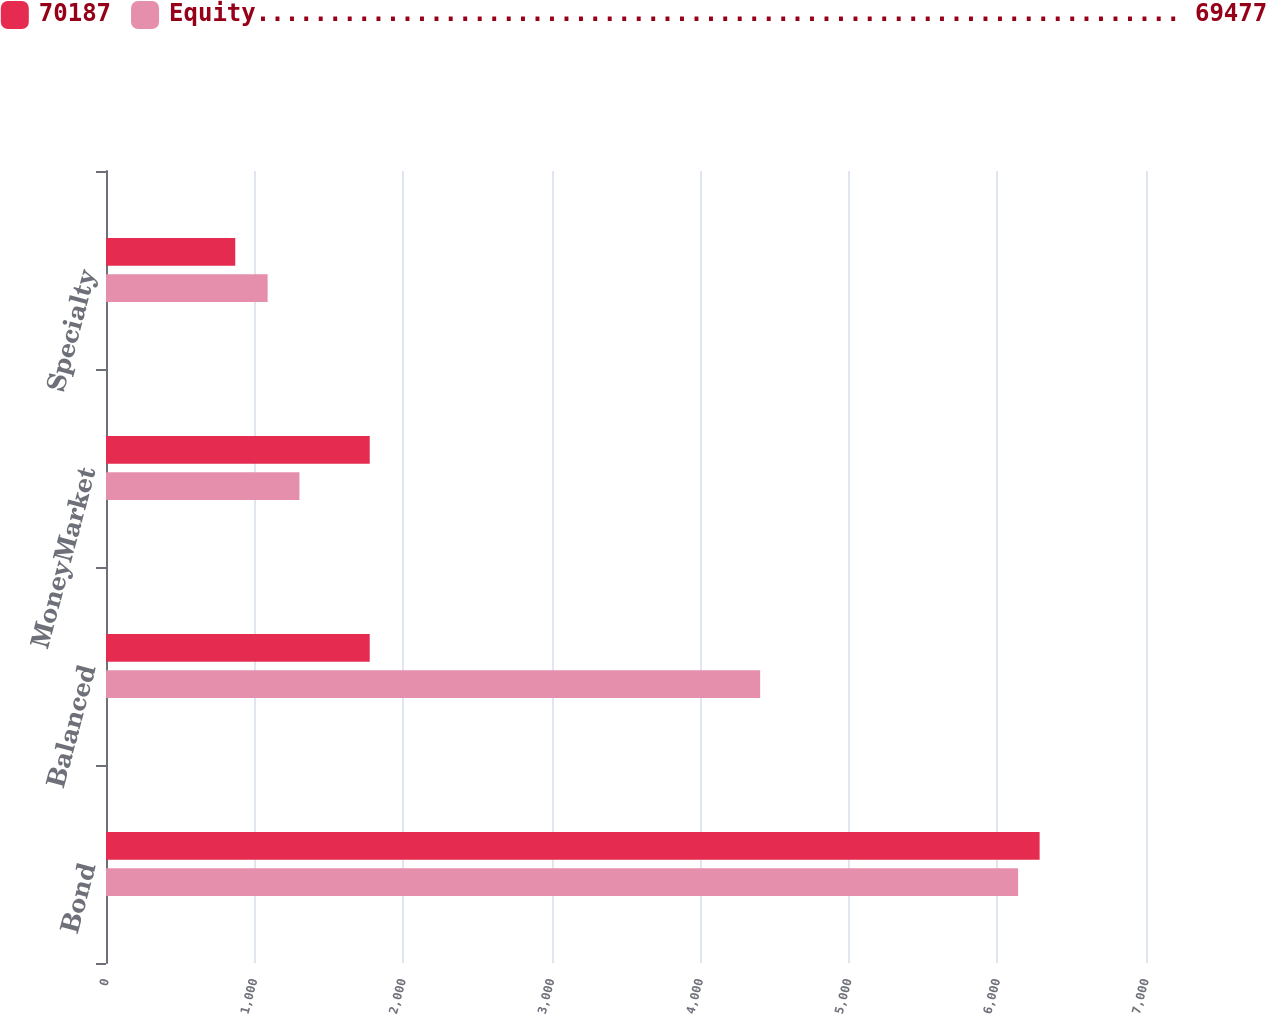Convert chart to OTSL. <chart><loc_0><loc_0><loc_500><loc_500><stacked_bar_chart><ecel><fcel>Bond<fcel>Balanced<fcel>MoneyMarket<fcel>Specialty<nl><fcel>70187<fcel>6284<fcel>1775<fcel>1775<fcel>870<nl><fcel>Equity................................................................ 69477<fcel>6139<fcel>4403<fcel>1302<fcel>1088<nl></chart> 